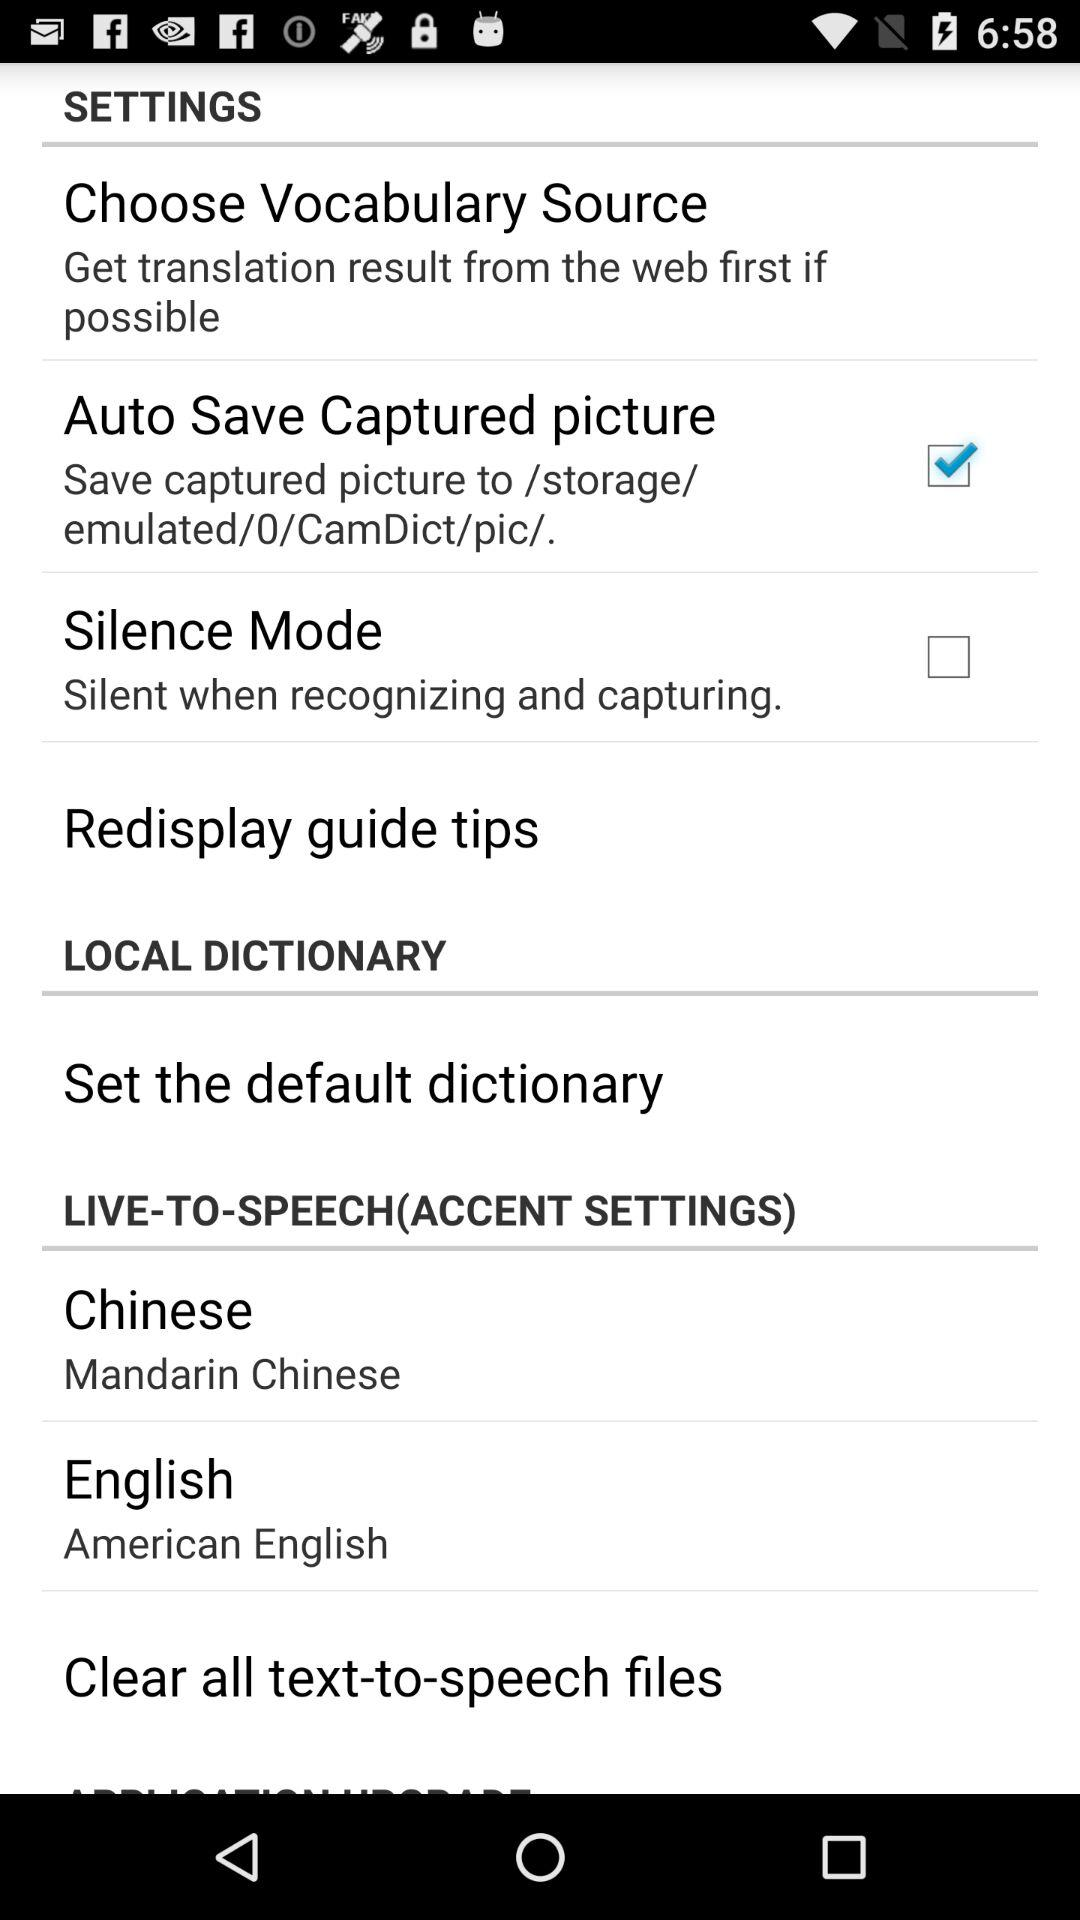Which Chinese accent is selected? The selected Chinese accent is Mandarin Chinese. 